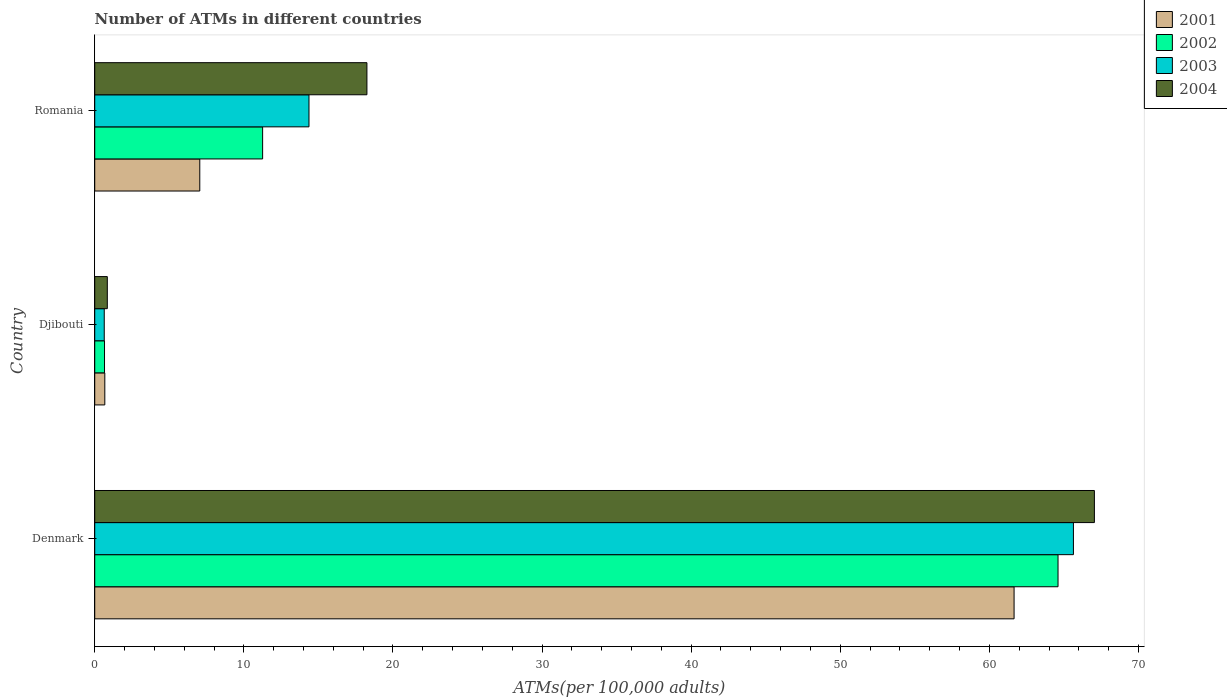Are the number of bars per tick equal to the number of legend labels?
Keep it short and to the point. Yes. Are the number of bars on each tick of the Y-axis equal?
Make the answer very short. Yes. How many bars are there on the 2nd tick from the top?
Your answer should be very brief. 4. How many bars are there on the 1st tick from the bottom?
Your response must be concise. 4. What is the label of the 1st group of bars from the top?
Your response must be concise. Romania. What is the number of ATMs in 2001 in Romania?
Offer a very short reply. 7.04. Across all countries, what is the maximum number of ATMs in 2003?
Your answer should be compact. 65.64. Across all countries, what is the minimum number of ATMs in 2003?
Your answer should be compact. 0.64. In which country was the number of ATMs in 2002 minimum?
Give a very brief answer. Djibouti. What is the total number of ATMs in 2003 in the graph?
Offer a terse response. 80.65. What is the difference between the number of ATMs in 2001 in Djibouti and that in Romania?
Your answer should be very brief. -6.37. What is the difference between the number of ATMs in 2001 in Denmark and the number of ATMs in 2002 in Djibouti?
Provide a succinct answer. 61. What is the average number of ATMs in 2004 per country?
Offer a very short reply. 28.71. What is the difference between the number of ATMs in 2004 and number of ATMs in 2003 in Romania?
Your answer should be compact. 3.89. In how many countries, is the number of ATMs in 2004 greater than 54 ?
Provide a succinct answer. 1. What is the ratio of the number of ATMs in 2001 in Djibouti to that in Romania?
Make the answer very short. 0.1. What is the difference between the highest and the second highest number of ATMs in 2004?
Keep it short and to the point. 48.79. What is the difference between the highest and the lowest number of ATMs in 2003?
Keep it short and to the point. 65. In how many countries, is the number of ATMs in 2001 greater than the average number of ATMs in 2001 taken over all countries?
Ensure brevity in your answer.  1. Is the sum of the number of ATMs in 2003 in Denmark and Djibouti greater than the maximum number of ATMs in 2004 across all countries?
Ensure brevity in your answer.  No. Is it the case that in every country, the sum of the number of ATMs in 2004 and number of ATMs in 2003 is greater than the number of ATMs in 2002?
Your answer should be very brief. Yes. Are all the bars in the graph horizontal?
Keep it short and to the point. Yes. How many countries are there in the graph?
Give a very brief answer. 3. What is the difference between two consecutive major ticks on the X-axis?
Ensure brevity in your answer.  10. Does the graph contain any zero values?
Offer a terse response. No. Does the graph contain grids?
Make the answer very short. No. Where does the legend appear in the graph?
Offer a very short reply. Top right. How are the legend labels stacked?
Make the answer very short. Vertical. What is the title of the graph?
Your answer should be compact. Number of ATMs in different countries. What is the label or title of the X-axis?
Provide a short and direct response. ATMs(per 100,0 adults). What is the label or title of the Y-axis?
Provide a succinct answer. Country. What is the ATMs(per 100,000 adults) of 2001 in Denmark?
Make the answer very short. 61.66. What is the ATMs(per 100,000 adults) of 2002 in Denmark?
Give a very brief answer. 64.61. What is the ATMs(per 100,000 adults) of 2003 in Denmark?
Offer a very short reply. 65.64. What is the ATMs(per 100,000 adults) in 2004 in Denmark?
Make the answer very short. 67.04. What is the ATMs(per 100,000 adults) in 2001 in Djibouti?
Provide a short and direct response. 0.68. What is the ATMs(per 100,000 adults) in 2002 in Djibouti?
Your answer should be very brief. 0.66. What is the ATMs(per 100,000 adults) of 2003 in Djibouti?
Ensure brevity in your answer.  0.64. What is the ATMs(per 100,000 adults) in 2004 in Djibouti?
Offer a terse response. 0.84. What is the ATMs(per 100,000 adults) in 2001 in Romania?
Give a very brief answer. 7.04. What is the ATMs(per 100,000 adults) of 2002 in Romania?
Make the answer very short. 11.26. What is the ATMs(per 100,000 adults) in 2003 in Romania?
Provide a succinct answer. 14.37. What is the ATMs(per 100,000 adults) of 2004 in Romania?
Give a very brief answer. 18.26. Across all countries, what is the maximum ATMs(per 100,000 adults) in 2001?
Give a very brief answer. 61.66. Across all countries, what is the maximum ATMs(per 100,000 adults) of 2002?
Provide a succinct answer. 64.61. Across all countries, what is the maximum ATMs(per 100,000 adults) in 2003?
Offer a very short reply. 65.64. Across all countries, what is the maximum ATMs(per 100,000 adults) in 2004?
Your answer should be compact. 67.04. Across all countries, what is the minimum ATMs(per 100,000 adults) in 2001?
Offer a terse response. 0.68. Across all countries, what is the minimum ATMs(per 100,000 adults) of 2002?
Make the answer very short. 0.66. Across all countries, what is the minimum ATMs(per 100,000 adults) of 2003?
Provide a succinct answer. 0.64. Across all countries, what is the minimum ATMs(per 100,000 adults) of 2004?
Offer a terse response. 0.84. What is the total ATMs(per 100,000 adults) of 2001 in the graph?
Your answer should be very brief. 69.38. What is the total ATMs(per 100,000 adults) of 2002 in the graph?
Provide a short and direct response. 76.52. What is the total ATMs(per 100,000 adults) of 2003 in the graph?
Make the answer very short. 80.65. What is the total ATMs(per 100,000 adults) of 2004 in the graph?
Keep it short and to the point. 86.14. What is the difference between the ATMs(per 100,000 adults) in 2001 in Denmark and that in Djibouti?
Provide a short and direct response. 60.98. What is the difference between the ATMs(per 100,000 adults) in 2002 in Denmark and that in Djibouti?
Your answer should be very brief. 63.95. What is the difference between the ATMs(per 100,000 adults) of 2003 in Denmark and that in Djibouti?
Keep it short and to the point. 65. What is the difference between the ATMs(per 100,000 adults) of 2004 in Denmark and that in Djibouti?
Ensure brevity in your answer.  66.2. What is the difference between the ATMs(per 100,000 adults) in 2001 in Denmark and that in Romania?
Give a very brief answer. 54.61. What is the difference between the ATMs(per 100,000 adults) in 2002 in Denmark and that in Romania?
Your response must be concise. 53.35. What is the difference between the ATMs(per 100,000 adults) in 2003 in Denmark and that in Romania?
Provide a succinct answer. 51.27. What is the difference between the ATMs(per 100,000 adults) of 2004 in Denmark and that in Romania?
Your answer should be very brief. 48.79. What is the difference between the ATMs(per 100,000 adults) in 2001 in Djibouti and that in Romania?
Keep it short and to the point. -6.37. What is the difference between the ATMs(per 100,000 adults) in 2002 in Djibouti and that in Romania?
Your answer should be very brief. -10.6. What is the difference between the ATMs(per 100,000 adults) in 2003 in Djibouti and that in Romania?
Your response must be concise. -13.73. What is the difference between the ATMs(per 100,000 adults) of 2004 in Djibouti and that in Romania?
Provide a short and direct response. -17.41. What is the difference between the ATMs(per 100,000 adults) of 2001 in Denmark and the ATMs(per 100,000 adults) of 2002 in Djibouti?
Make the answer very short. 61. What is the difference between the ATMs(per 100,000 adults) in 2001 in Denmark and the ATMs(per 100,000 adults) in 2003 in Djibouti?
Offer a very short reply. 61.02. What is the difference between the ATMs(per 100,000 adults) in 2001 in Denmark and the ATMs(per 100,000 adults) in 2004 in Djibouti?
Ensure brevity in your answer.  60.81. What is the difference between the ATMs(per 100,000 adults) of 2002 in Denmark and the ATMs(per 100,000 adults) of 2003 in Djibouti?
Give a very brief answer. 63.97. What is the difference between the ATMs(per 100,000 adults) of 2002 in Denmark and the ATMs(per 100,000 adults) of 2004 in Djibouti?
Make the answer very short. 63.76. What is the difference between the ATMs(per 100,000 adults) of 2003 in Denmark and the ATMs(per 100,000 adults) of 2004 in Djibouti?
Keep it short and to the point. 64.79. What is the difference between the ATMs(per 100,000 adults) of 2001 in Denmark and the ATMs(per 100,000 adults) of 2002 in Romania?
Your answer should be very brief. 50.4. What is the difference between the ATMs(per 100,000 adults) in 2001 in Denmark and the ATMs(per 100,000 adults) in 2003 in Romania?
Give a very brief answer. 47.29. What is the difference between the ATMs(per 100,000 adults) of 2001 in Denmark and the ATMs(per 100,000 adults) of 2004 in Romania?
Your answer should be very brief. 43.4. What is the difference between the ATMs(per 100,000 adults) of 2002 in Denmark and the ATMs(per 100,000 adults) of 2003 in Romania?
Ensure brevity in your answer.  50.24. What is the difference between the ATMs(per 100,000 adults) of 2002 in Denmark and the ATMs(per 100,000 adults) of 2004 in Romania?
Your answer should be compact. 46.35. What is the difference between the ATMs(per 100,000 adults) in 2003 in Denmark and the ATMs(per 100,000 adults) in 2004 in Romania?
Offer a terse response. 47.38. What is the difference between the ATMs(per 100,000 adults) in 2001 in Djibouti and the ATMs(per 100,000 adults) in 2002 in Romania?
Offer a very short reply. -10.58. What is the difference between the ATMs(per 100,000 adults) in 2001 in Djibouti and the ATMs(per 100,000 adults) in 2003 in Romania?
Provide a succinct answer. -13.69. What is the difference between the ATMs(per 100,000 adults) of 2001 in Djibouti and the ATMs(per 100,000 adults) of 2004 in Romania?
Keep it short and to the point. -17.58. What is the difference between the ATMs(per 100,000 adults) in 2002 in Djibouti and the ATMs(per 100,000 adults) in 2003 in Romania?
Your answer should be compact. -13.71. What is the difference between the ATMs(per 100,000 adults) in 2002 in Djibouti and the ATMs(per 100,000 adults) in 2004 in Romania?
Your response must be concise. -17.6. What is the difference between the ATMs(per 100,000 adults) in 2003 in Djibouti and the ATMs(per 100,000 adults) in 2004 in Romania?
Offer a terse response. -17.62. What is the average ATMs(per 100,000 adults) of 2001 per country?
Offer a terse response. 23.13. What is the average ATMs(per 100,000 adults) of 2002 per country?
Your answer should be compact. 25.51. What is the average ATMs(per 100,000 adults) of 2003 per country?
Ensure brevity in your answer.  26.88. What is the average ATMs(per 100,000 adults) of 2004 per country?
Make the answer very short. 28.71. What is the difference between the ATMs(per 100,000 adults) of 2001 and ATMs(per 100,000 adults) of 2002 in Denmark?
Your response must be concise. -2.95. What is the difference between the ATMs(per 100,000 adults) in 2001 and ATMs(per 100,000 adults) in 2003 in Denmark?
Ensure brevity in your answer.  -3.98. What is the difference between the ATMs(per 100,000 adults) in 2001 and ATMs(per 100,000 adults) in 2004 in Denmark?
Offer a terse response. -5.39. What is the difference between the ATMs(per 100,000 adults) of 2002 and ATMs(per 100,000 adults) of 2003 in Denmark?
Offer a terse response. -1.03. What is the difference between the ATMs(per 100,000 adults) of 2002 and ATMs(per 100,000 adults) of 2004 in Denmark?
Your answer should be compact. -2.44. What is the difference between the ATMs(per 100,000 adults) in 2003 and ATMs(per 100,000 adults) in 2004 in Denmark?
Offer a terse response. -1.41. What is the difference between the ATMs(per 100,000 adults) of 2001 and ATMs(per 100,000 adults) of 2002 in Djibouti?
Provide a short and direct response. 0.02. What is the difference between the ATMs(per 100,000 adults) in 2001 and ATMs(per 100,000 adults) in 2003 in Djibouti?
Your response must be concise. 0.04. What is the difference between the ATMs(per 100,000 adults) in 2001 and ATMs(per 100,000 adults) in 2004 in Djibouti?
Keep it short and to the point. -0.17. What is the difference between the ATMs(per 100,000 adults) in 2002 and ATMs(per 100,000 adults) in 2003 in Djibouti?
Your answer should be compact. 0.02. What is the difference between the ATMs(per 100,000 adults) of 2002 and ATMs(per 100,000 adults) of 2004 in Djibouti?
Provide a short and direct response. -0.19. What is the difference between the ATMs(per 100,000 adults) of 2003 and ATMs(per 100,000 adults) of 2004 in Djibouti?
Give a very brief answer. -0.21. What is the difference between the ATMs(per 100,000 adults) in 2001 and ATMs(per 100,000 adults) in 2002 in Romania?
Make the answer very short. -4.21. What is the difference between the ATMs(per 100,000 adults) in 2001 and ATMs(per 100,000 adults) in 2003 in Romania?
Offer a terse response. -7.32. What is the difference between the ATMs(per 100,000 adults) of 2001 and ATMs(per 100,000 adults) of 2004 in Romania?
Provide a succinct answer. -11.21. What is the difference between the ATMs(per 100,000 adults) of 2002 and ATMs(per 100,000 adults) of 2003 in Romania?
Keep it short and to the point. -3.11. What is the difference between the ATMs(per 100,000 adults) of 2002 and ATMs(per 100,000 adults) of 2004 in Romania?
Give a very brief answer. -7. What is the difference between the ATMs(per 100,000 adults) of 2003 and ATMs(per 100,000 adults) of 2004 in Romania?
Provide a short and direct response. -3.89. What is the ratio of the ATMs(per 100,000 adults) of 2001 in Denmark to that in Djibouti?
Give a very brief answer. 91.18. What is the ratio of the ATMs(per 100,000 adults) in 2002 in Denmark to that in Djibouti?
Provide a succinct answer. 98.45. What is the ratio of the ATMs(per 100,000 adults) in 2003 in Denmark to that in Djibouti?
Keep it short and to the point. 102.88. What is the ratio of the ATMs(per 100,000 adults) in 2004 in Denmark to that in Djibouti?
Your response must be concise. 79.46. What is the ratio of the ATMs(per 100,000 adults) of 2001 in Denmark to that in Romania?
Offer a very short reply. 8.75. What is the ratio of the ATMs(per 100,000 adults) of 2002 in Denmark to that in Romania?
Give a very brief answer. 5.74. What is the ratio of the ATMs(per 100,000 adults) of 2003 in Denmark to that in Romania?
Give a very brief answer. 4.57. What is the ratio of the ATMs(per 100,000 adults) of 2004 in Denmark to that in Romania?
Ensure brevity in your answer.  3.67. What is the ratio of the ATMs(per 100,000 adults) of 2001 in Djibouti to that in Romania?
Your answer should be very brief. 0.1. What is the ratio of the ATMs(per 100,000 adults) of 2002 in Djibouti to that in Romania?
Offer a terse response. 0.06. What is the ratio of the ATMs(per 100,000 adults) of 2003 in Djibouti to that in Romania?
Offer a very short reply. 0.04. What is the ratio of the ATMs(per 100,000 adults) of 2004 in Djibouti to that in Romania?
Keep it short and to the point. 0.05. What is the difference between the highest and the second highest ATMs(per 100,000 adults) of 2001?
Offer a very short reply. 54.61. What is the difference between the highest and the second highest ATMs(per 100,000 adults) in 2002?
Give a very brief answer. 53.35. What is the difference between the highest and the second highest ATMs(per 100,000 adults) in 2003?
Ensure brevity in your answer.  51.27. What is the difference between the highest and the second highest ATMs(per 100,000 adults) in 2004?
Your response must be concise. 48.79. What is the difference between the highest and the lowest ATMs(per 100,000 adults) in 2001?
Offer a terse response. 60.98. What is the difference between the highest and the lowest ATMs(per 100,000 adults) in 2002?
Provide a succinct answer. 63.95. What is the difference between the highest and the lowest ATMs(per 100,000 adults) of 2003?
Ensure brevity in your answer.  65. What is the difference between the highest and the lowest ATMs(per 100,000 adults) in 2004?
Your answer should be very brief. 66.2. 